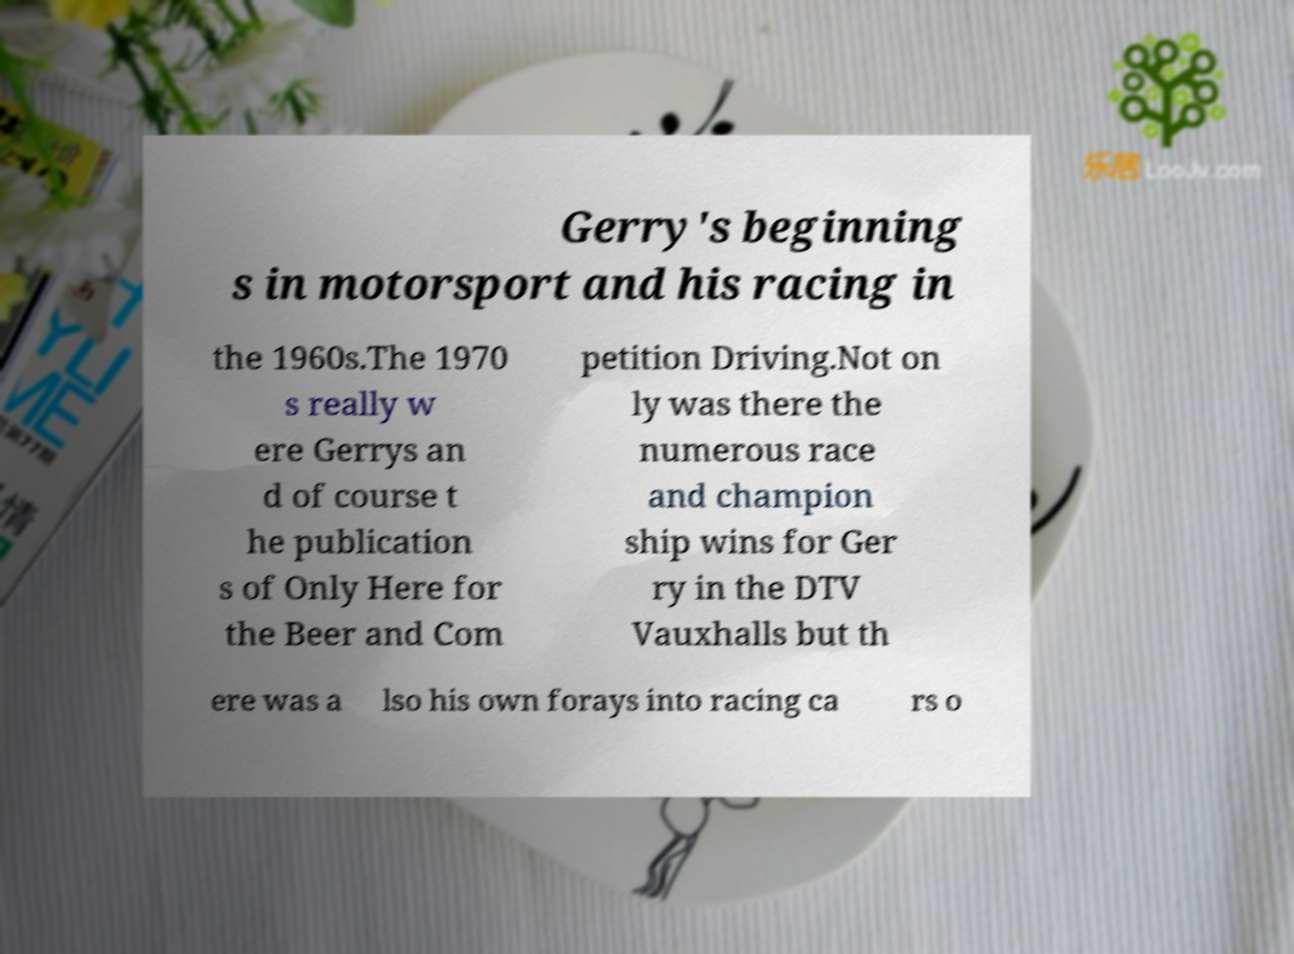Please identify and transcribe the text found in this image. Gerry's beginning s in motorsport and his racing in the 1960s.The 1970 s really w ere Gerrys an d of course t he publication s of Only Here for the Beer and Com petition Driving.Not on ly was there the numerous race and champion ship wins for Ger ry in the DTV Vauxhalls but th ere was a lso his own forays into racing ca rs o 